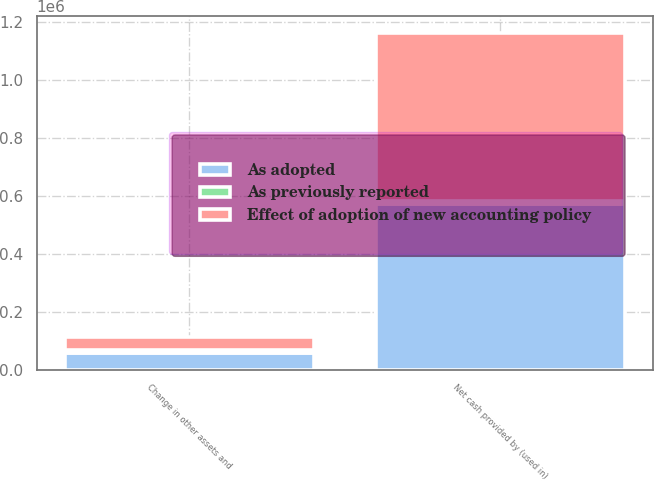Convert chart. <chart><loc_0><loc_0><loc_500><loc_500><stacked_bar_chart><ecel><fcel>Change in other assets and<fcel>Net cash provided by (used in)<nl><fcel>As adopted<fcel>56204<fcel>570921<nl><fcel>As previously reported<fcel>10595<fcel>10595<nl><fcel>Effect of adoption of new accounting policy<fcel>45609<fcel>581516<nl></chart> 